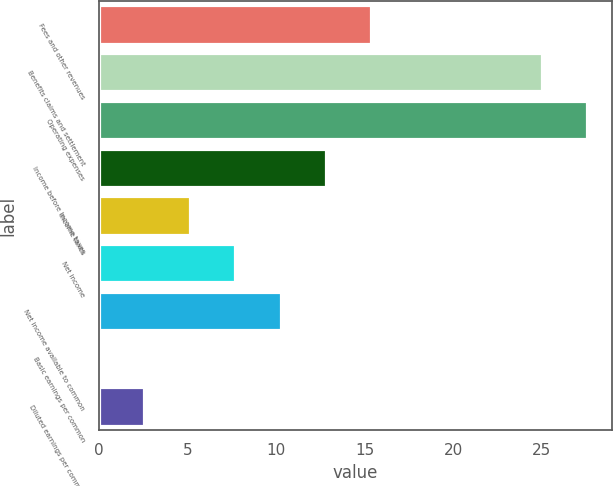<chart> <loc_0><loc_0><loc_500><loc_500><bar_chart><fcel>Fees and other revenues<fcel>Benefits claims and settlement<fcel>Operating expenses<fcel>Income before income taxes<fcel>Income taxes<fcel>Net income<fcel>Net income available to common<fcel>Basic earnings per common<fcel>Diluted earnings per common<nl><fcel>15.38<fcel>25<fcel>27.56<fcel>12.82<fcel>5.14<fcel>7.7<fcel>10.26<fcel>0.02<fcel>2.58<nl></chart> 